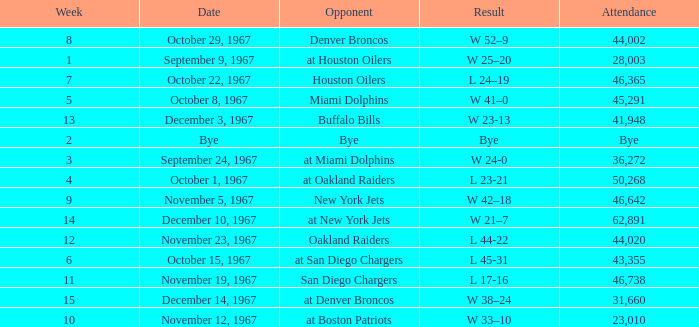What week did the September 9, 1967 game occur on? 1.0. 